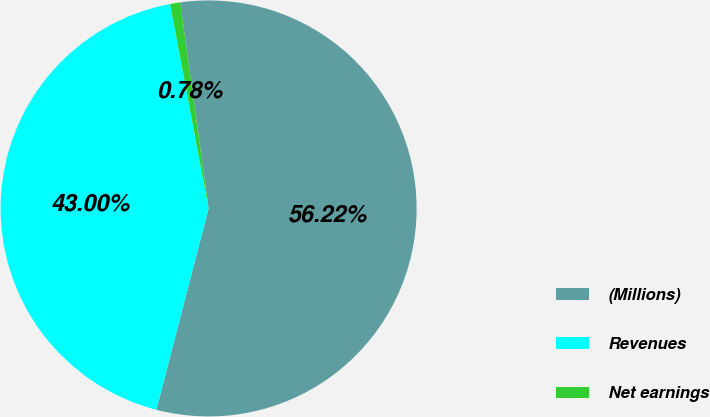Convert chart to OTSL. <chart><loc_0><loc_0><loc_500><loc_500><pie_chart><fcel>(Millions)<fcel>Revenues<fcel>Net earnings<nl><fcel>56.22%<fcel>43.0%<fcel>0.78%<nl></chart> 